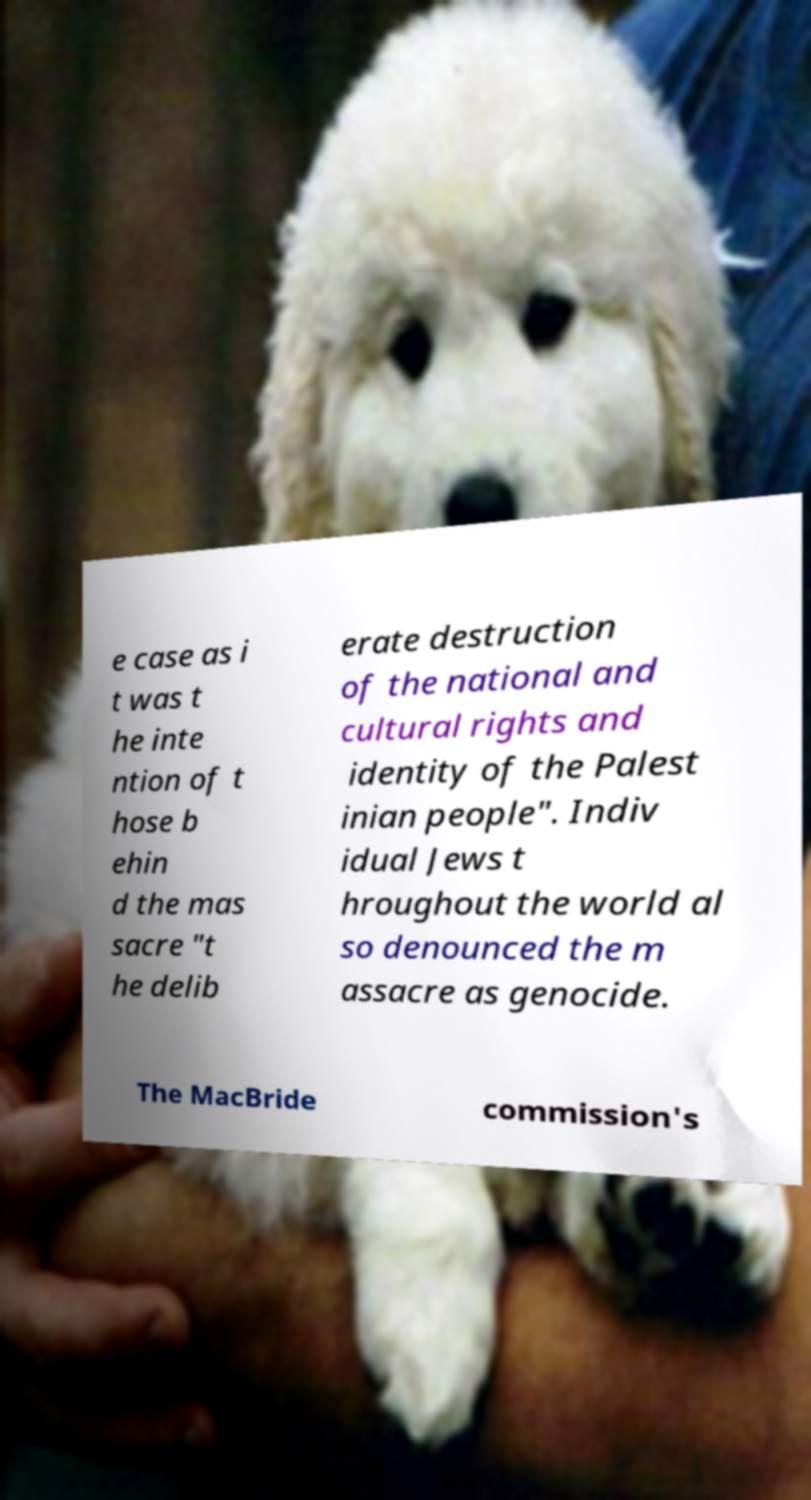Can you accurately transcribe the text from the provided image for me? e case as i t was t he inte ntion of t hose b ehin d the mas sacre "t he delib erate destruction of the national and cultural rights and identity of the Palest inian people". Indiv idual Jews t hroughout the world al so denounced the m assacre as genocide. The MacBride commission's 